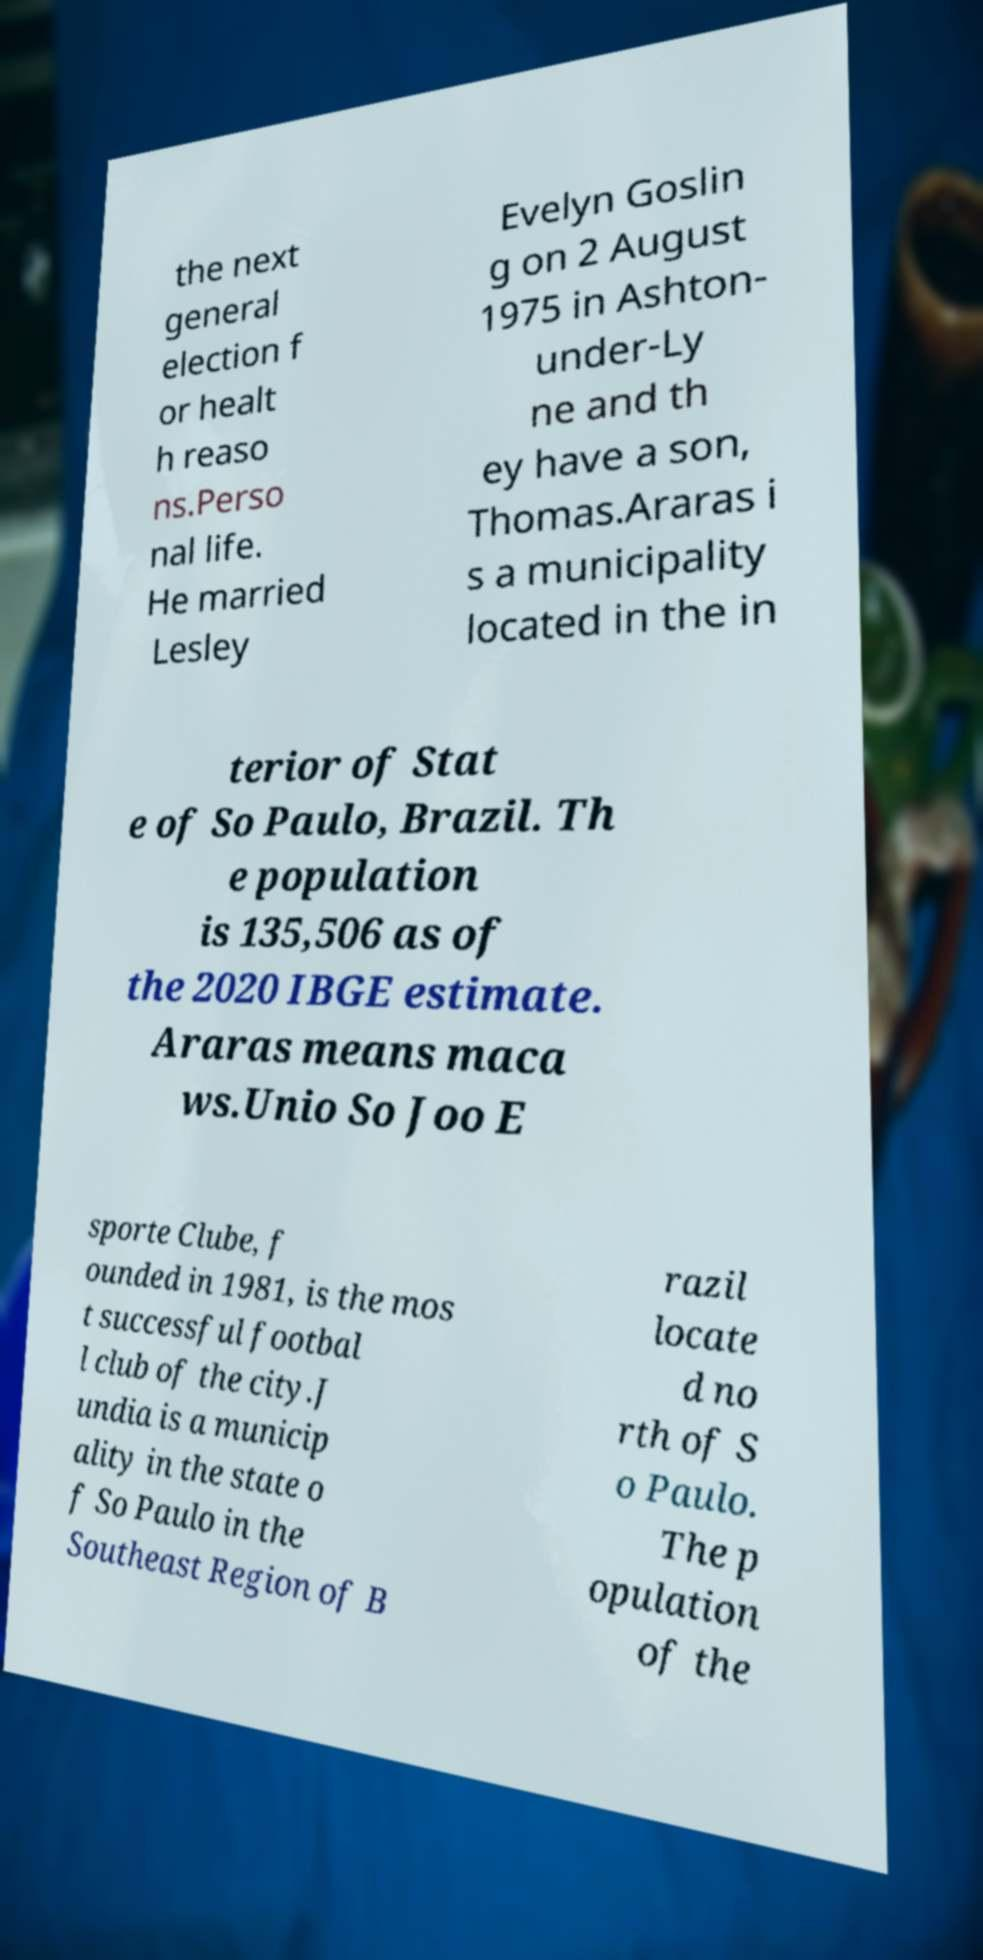Could you extract and type out the text from this image? the next general election f or healt h reaso ns.Perso nal life. He married Lesley Evelyn Goslin g on 2 August 1975 in Ashton- under-Ly ne and th ey have a son, Thomas.Araras i s a municipality located in the in terior of Stat e of So Paulo, Brazil. Th e population is 135,506 as of the 2020 IBGE estimate. Araras means maca ws.Unio So Joo E sporte Clube, f ounded in 1981, is the mos t successful footbal l club of the city.J undia is a municip ality in the state o f So Paulo in the Southeast Region of B razil locate d no rth of S o Paulo. The p opulation of the 